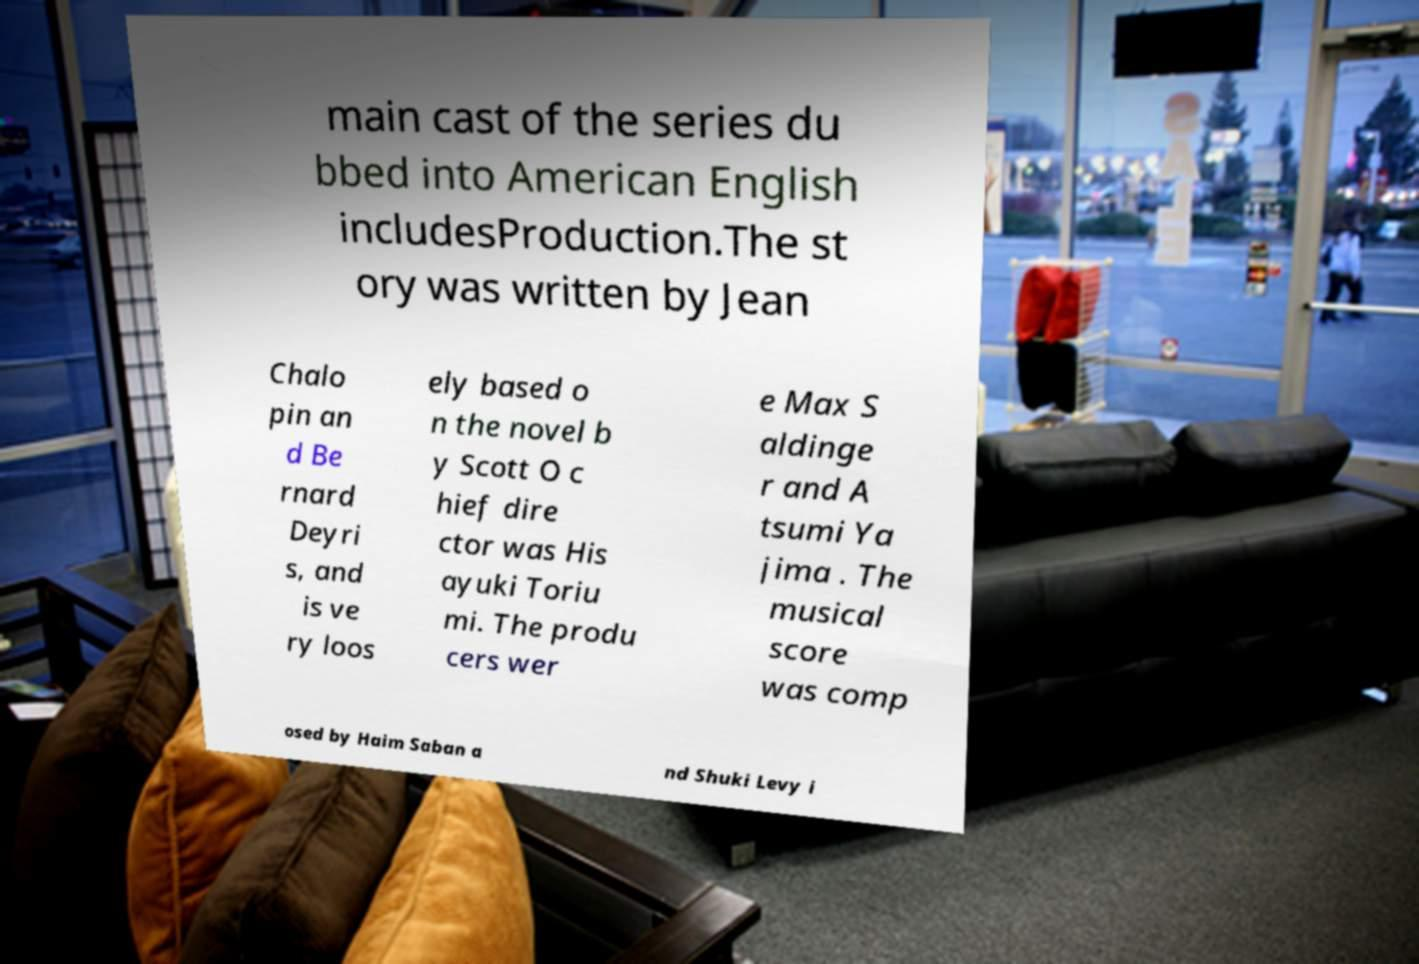Could you assist in decoding the text presented in this image and type it out clearly? main cast of the series du bbed into American English includesProduction.The st ory was written by Jean Chalo pin an d Be rnard Deyri s, and is ve ry loos ely based o n the novel b y Scott O c hief dire ctor was His ayuki Toriu mi. The produ cers wer e Max S aldinge r and A tsumi Ya jima . The musical score was comp osed by Haim Saban a nd Shuki Levy i 